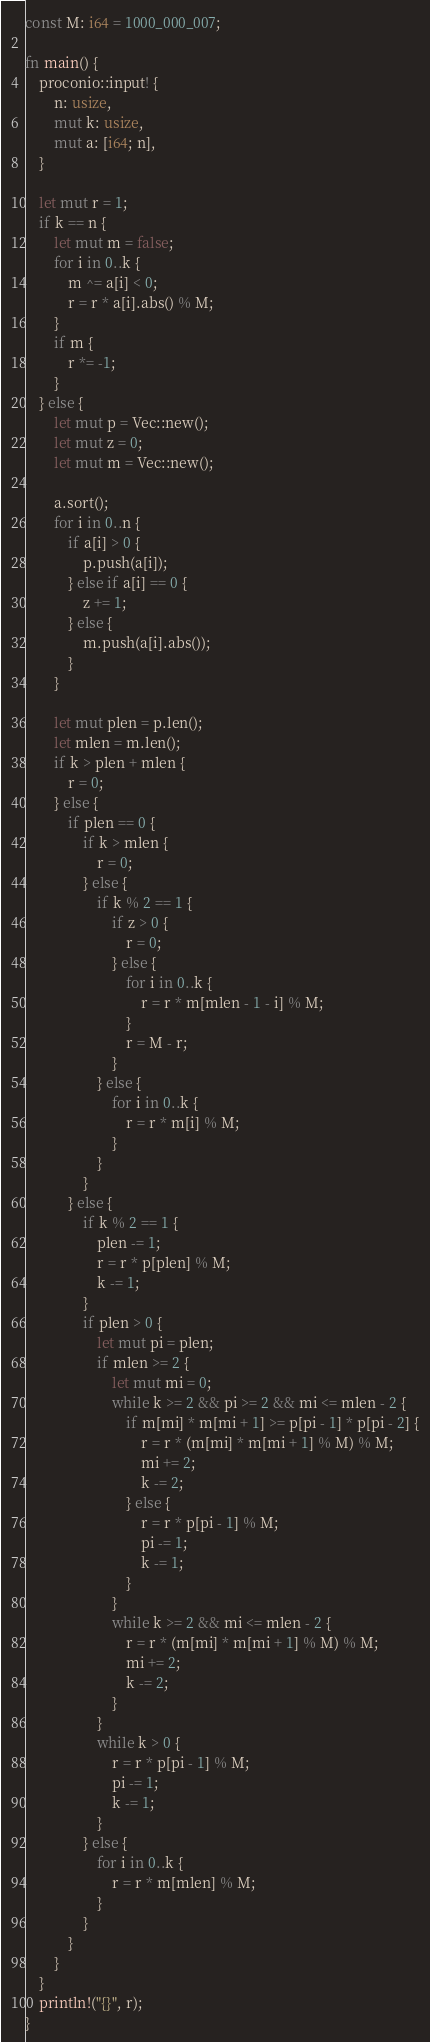<code> <loc_0><loc_0><loc_500><loc_500><_Rust_>const M: i64 = 1000_000_007;

fn main() {
    proconio::input! {
        n: usize,
        mut k: usize,
        mut a: [i64; n],
    }

    let mut r = 1;
    if k == n {
        let mut m = false;
        for i in 0..k {
            m ^= a[i] < 0;
            r = r * a[i].abs() % M;
        }
        if m {
            r *= -1;
        }
    } else {
        let mut p = Vec::new();
        let mut z = 0;
        let mut m = Vec::new();

        a.sort();
        for i in 0..n {
            if a[i] > 0 {
                p.push(a[i]);
            } else if a[i] == 0 {
                z += 1;
            } else {
                m.push(a[i].abs());
            }
        }

        let mut plen = p.len();
        let mlen = m.len();
        if k > plen + mlen {
            r = 0;
        } else {
            if plen == 0 {
                if k > mlen {
                    r = 0;
                } else {
                    if k % 2 == 1 {
                        if z > 0 {
                            r = 0;
                        } else {
                            for i in 0..k {
                                r = r * m[mlen - 1 - i] % M;
                            }
                            r = M - r;
                        }
                    } else {
                        for i in 0..k {
                            r = r * m[i] % M;
                        }
                    }
                }
            } else {
                if k % 2 == 1 {
                    plen -= 1;
                    r = r * p[plen] % M;
                    k -= 1;
                }
                if plen > 0 {
                    let mut pi = plen;
                    if mlen >= 2 {
                        let mut mi = 0;
                        while k >= 2 && pi >= 2 && mi <= mlen - 2 {
                            if m[mi] * m[mi + 1] >= p[pi - 1] * p[pi - 2] {
                                r = r * (m[mi] * m[mi + 1] % M) % M;
                                mi += 2;
                                k -= 2;
                            } else {
                                r = r * p[pi - 1] % M;
                                pi -= 1;
                                k -= 1;
                            }
                        }
                        while k >= 2 && mi <= mlen - 2 {
                            r = r * (m[mi] * m[mi + 1] % M) % M;
                            mi += 2;
                            k -= 2;
                        }
                    }
                    while k > 0 {
                        r = r * p[pi - 1] % M;
                        pi -= 1;
                        k -= 1;
                    }
                } else {
                    for i in 0..k {
                        r = r * m[mlen] % M;
                    }
                }
            }
        }
    }
    println!("{}", r);
}
</code> 